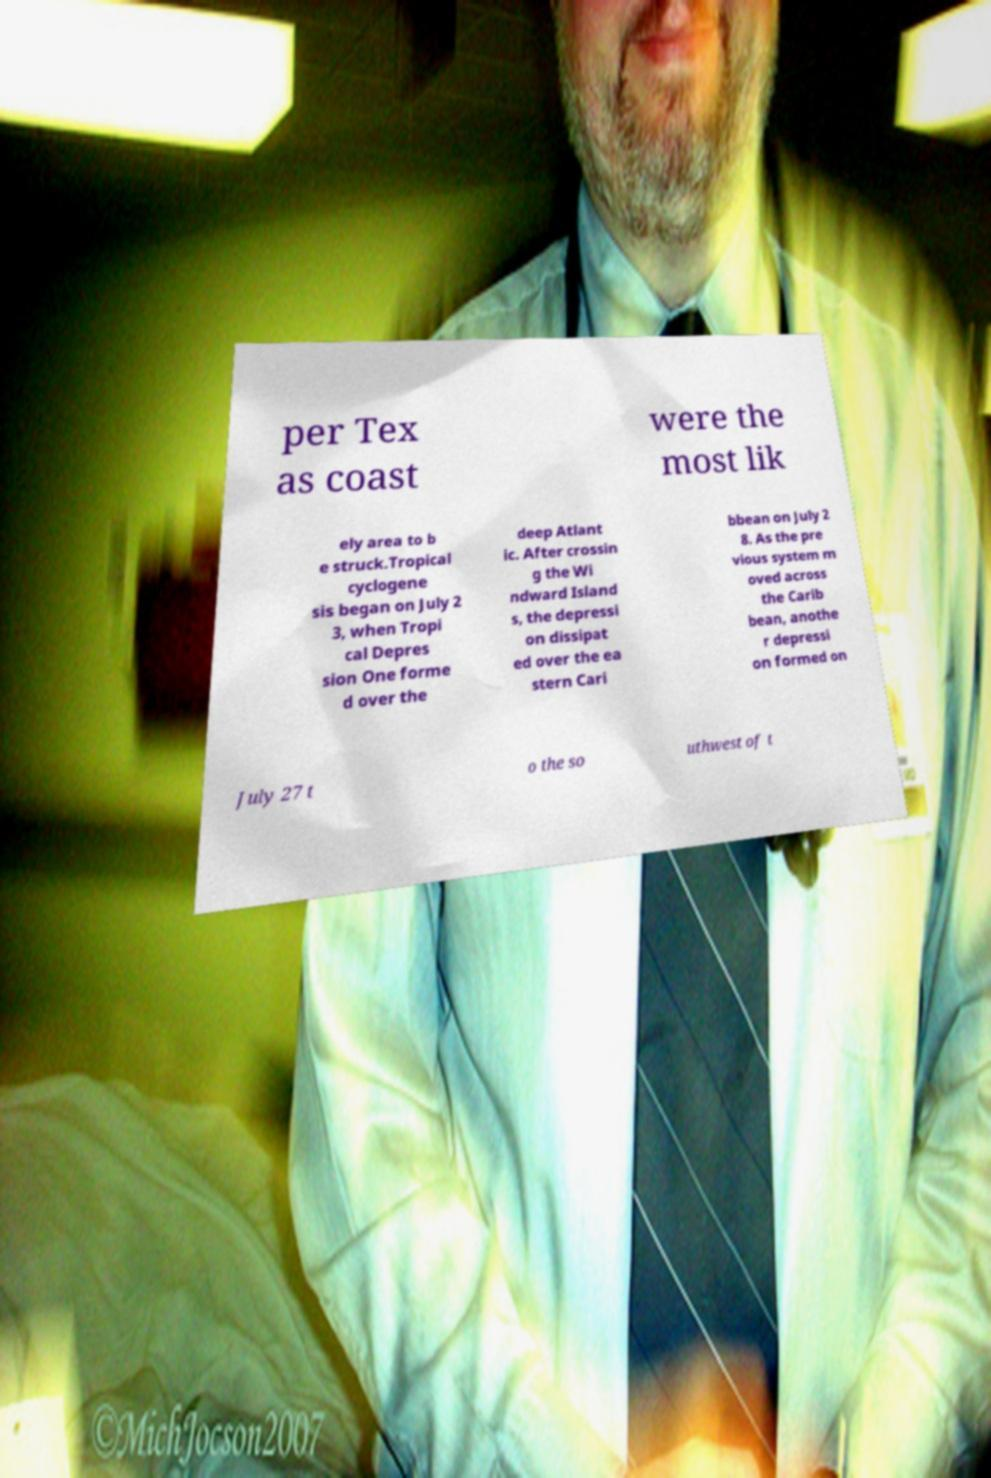Please read and relay the text visible in this image. What does it say? per Tex as coast were the most lik ely area to b e struck.Tropical cyclogene sis began on July 2 3, when Tropi cal Depres sion One forme d over the deep Atlant ic. After crossin g the Wi ndward Island s, the depressi on dissipat ed over the ea stern Cari bbean on July 2 8. As the pre vious system m oved across the Carib bean, anothe r depressi on formed on July 27 t o the so uthwest of t 